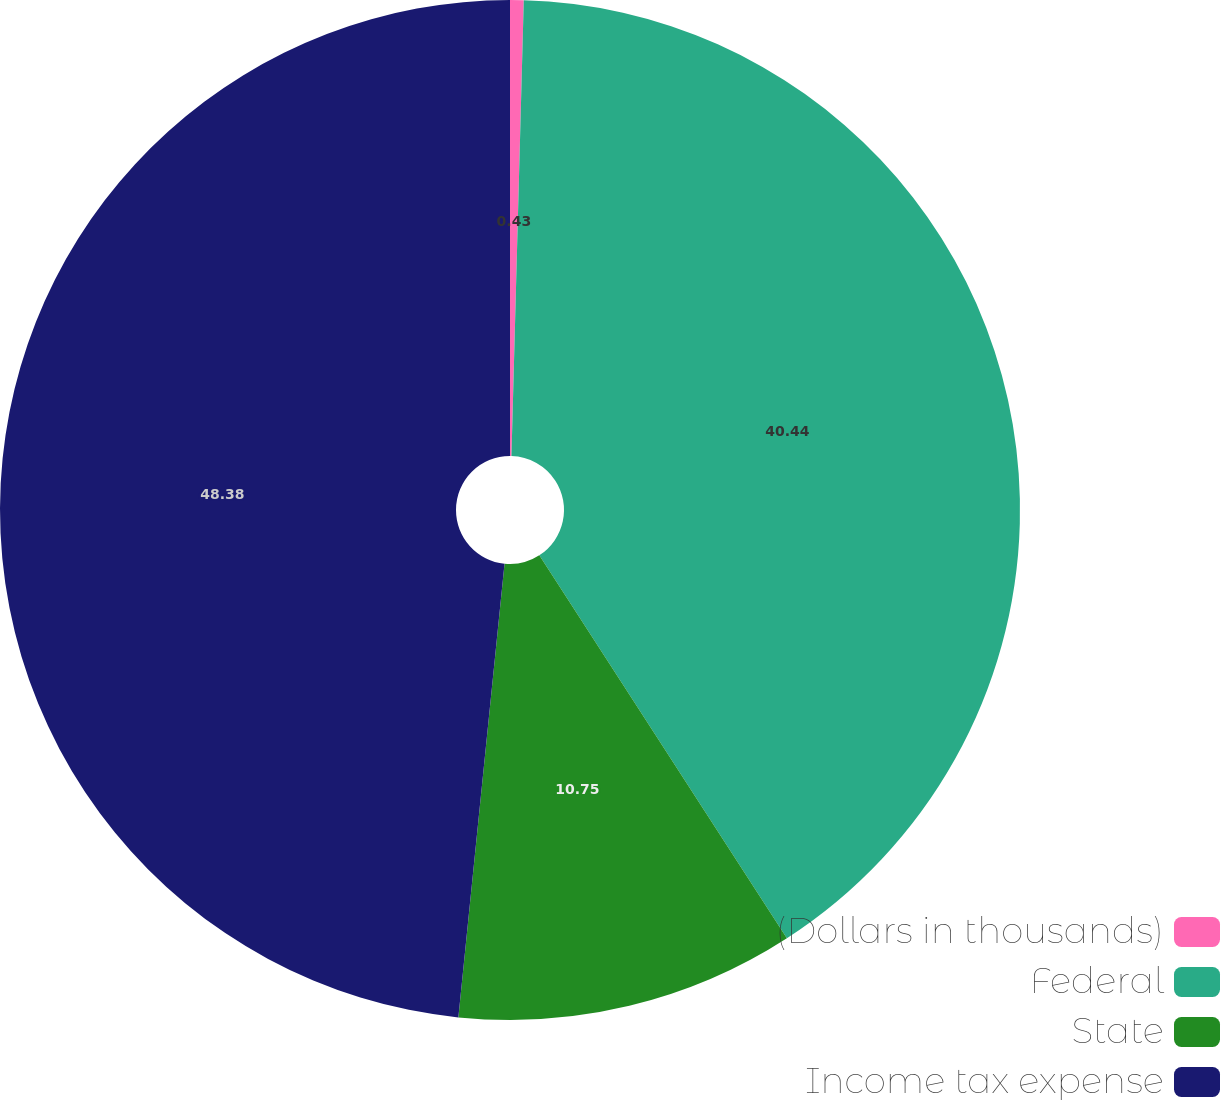Convert chart to OTSL. <chart><loc_0><loc_0><loc_500><loc_500><pie_chart><fcel>(Dollars in thousands)<fcel>Federal<fcel>State<fcel>Income tax expense<nl><fcel>0.43%<fcel>40.44%<fcel>10.75%<fcel>48.39%<nl></chart> 